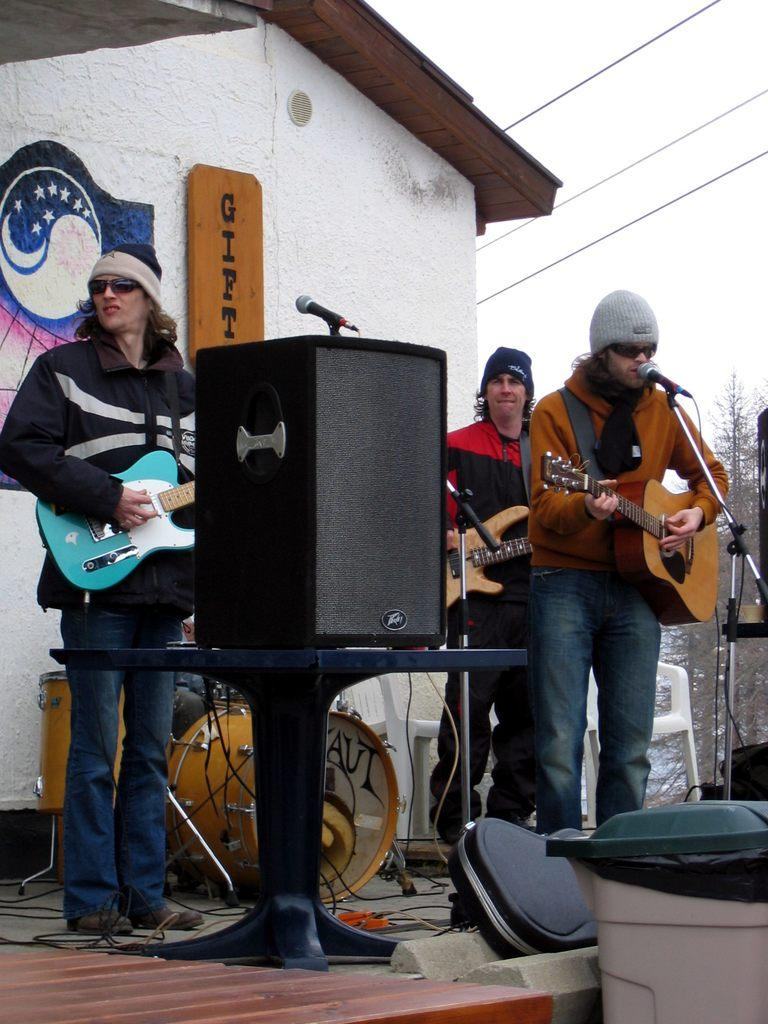How many people are in the image? There are three persons in the image. What are the persons doing in the image? The persons are standing and holding guitars. What objects are present in the image that are related to music? There are microphones with stands and other musical instruments in the image. What can be seen in the background of the image? There is a wall and the sky visible in the image. Can you tell me how many bats are flying in the image? There are no bats visible in the image; it features three persons holding guitars and other musical elements. What type of toad can be seen sitting on the wall in the image? There is no toad present in the image; the wall is part of the background and does not have any animals on it. 